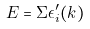<formula> <loc_0><loc_0><loc_500><loc_500>E = \Sigma \epsilon _ { i } ^ { \prime } ( k )</formula> 